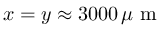Convert formula to latex. <formula><loc_0><loc_0><loc_500><loc_500>x = y \approx 3 0 0 0 \, \mu m</formula> 